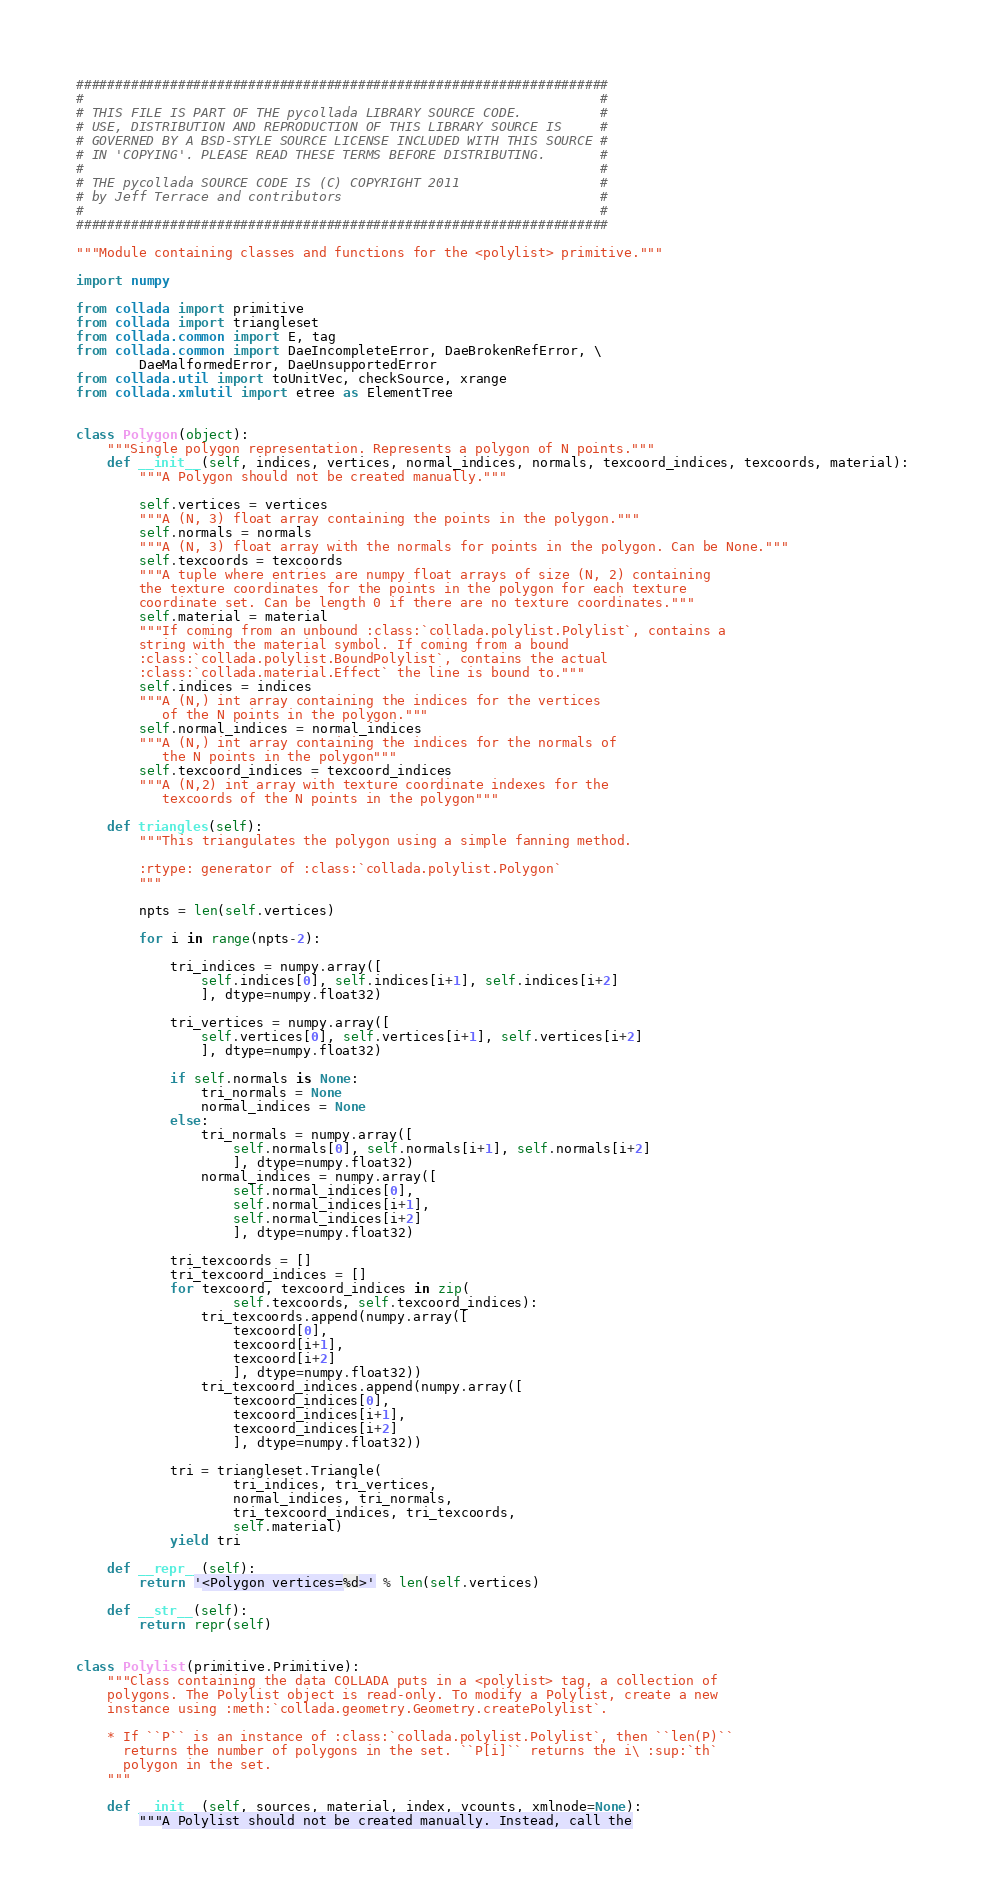Convert code to text. <code><loc_0><loc_0><loc_500><loc_500><_Python_>####################################################################
#                                                                  #
# THIS FILE IS PART OF THE pycollada LIBRARY SOURCE CODE.          #
# USE, DISTRIBUTION AND REPRODUCTION OF THIS LIBRARY SOURCE IS     #
# GOVERNED BY A BSD-STYLE SOURCE LICENSE INCLUDED WITH THIS SOURCE #
# IN 'COPYING'. PLEASE READ THESE TERMS BEFORE DISTRIBUTING.       #
#                                                                  #
# THE pycollada SOURCE CODE IS (C) COPYRIGHT 2011                  #
# by Jeff Terrace and contributors                                 #
#                                                                  #
####################################################################

"""Module containing classes and functions for the <polylist> primitive."""

import numpy

from collada import primitive
from collada import triangleset
from collada.common import E, tag
from collada.common import DaeIncompleteError, DaeBrokenRefError, \
        DaeMalformedError, DaeUnsupportedError
from collada.util import toUnitVec, checkSource, xrange
from collada.xmlutil import etree as ElementTree


class Polygon(object):
    """Single polygon representation. Represents a polygon of N points."""
    def __init__(self, indices, vertices, normal_indices, normals, texcoord_indices, texcoords, material):
        """A Polygon should not be created manually."""

        self.vertices = vertices
        """A (N, 3) float array containing the points in the polygon."""
        self.normals = normals
        """A (N, 3) float array with the normals for points in the polygon. Can be None."""
        self.texcoords = texcoords
        """A tuple where entries are numpy float arrays of size (N, 2) containing
        the texture coordinates for the points in the polygon for each texture
        coordinate set. Can be length 0 if there are no texture coordinates."""
        self.material = material
        """If coming from an unbound :class:`collada.polylist.Polylist`, contains a
        string with the material symbol. If coming from a bound
        :class:`collada.polylist.BoundPolylist`, contains the actual
        :class:`collada.material.Effect` the line is bound to."""
        self.indices = indices
        """A (N,) int array containing the indices for the vertices
           of the N points in the polygon."""
        self.normal_indices = normal_indices
        """A (N,) int array containing the indices for the normals of
           the N points in the polygon"""
        self.texcoord_indices = texcoord_indices
        """A (N,2) int array with texture coordinate indexes for the
           texcoords of the N points in the polygon"""

    def triangles(self):
        """This triangulates the polygon using a simple fanning method.

        :rtype: generator of :class:`collada.polylist.Polygon`
        """

        npts = len(self.vertices)

        for i in range(npts-2):

            tri_indices = numpy.array([
                self.indices[0], self.indices[i+1], self.indices[i+2]
                ], dtype=numpy.float32)

            tri_vertices = numpy.array([
                self.vertices[0], self.vertices[i+1], self.vertices[i+2]
                ], dtype=numpy.float32)

            if self.normals is None:
                tri_normals = None
                normal_indices = None
            else:
                tri_normals = numpy.array([
                    self.normals[0], self.normals[i+1], self.normals[i+2]
                    ], dtype=numpy.float32)
                normal_indices = numpy.array([
                    self.normal_indices[0],
                    self.normal_indices[i+1],
                    self.normal_indices[i+2]
                    ], dtype=numpy.float32)

            tri_texcoords = []
            tri_texcoord_indices = []
            for texcoord, texcoord_indices in zip(
                    self.texcoords, self.texcoord_indices):
                tri_texcoords.append(numpy.array([
                    texcoord[0],
                    texcoord[i+1],
                    texcoord[i+2]
                    ], dtype=numpy.float32))
                tri_texcoord_indices.append(numpy.array([
                    texcoord_indices[0],
                    texcoord_indices[i+1],
                    texcoord_indices[i+2]
                    ], dtype=numpy.float32))

            tri = triangleset.Triangle(
                    tri_indices, tri_vertices,
                    normal_indices, tri_normals,
                    tri_texcoord_indices, tri_texcoords,
                    self.material)
            yield tri

    def __repr__(self):
        return '<Polygon vertices=%d>' % len(self.vertices)

    def __str__(self):
        return repr(self)


class Polylist(primitive.Primitive):
    """Class containing the data COLLADA puts in a <polylist> tag, a collection of
    polygons. The Polylist object is read-only. To modify a Polylist, create a new
    instance using :meth:`collada.geometry.Geometry.createPolylist`.

    * If ``P`` is an instance of :class:`collada.polylist.Polylist`, then ``len(P)``
      returns the number of polygons in the set. ``P[i]`` returns the i\ :sup:`th`
      polygon in the set.
    """

    def __init__(self, sources, material, index, vcounts, xmlnode=None):
        """A Polylist should not be created manually. Instead, call the</code> 